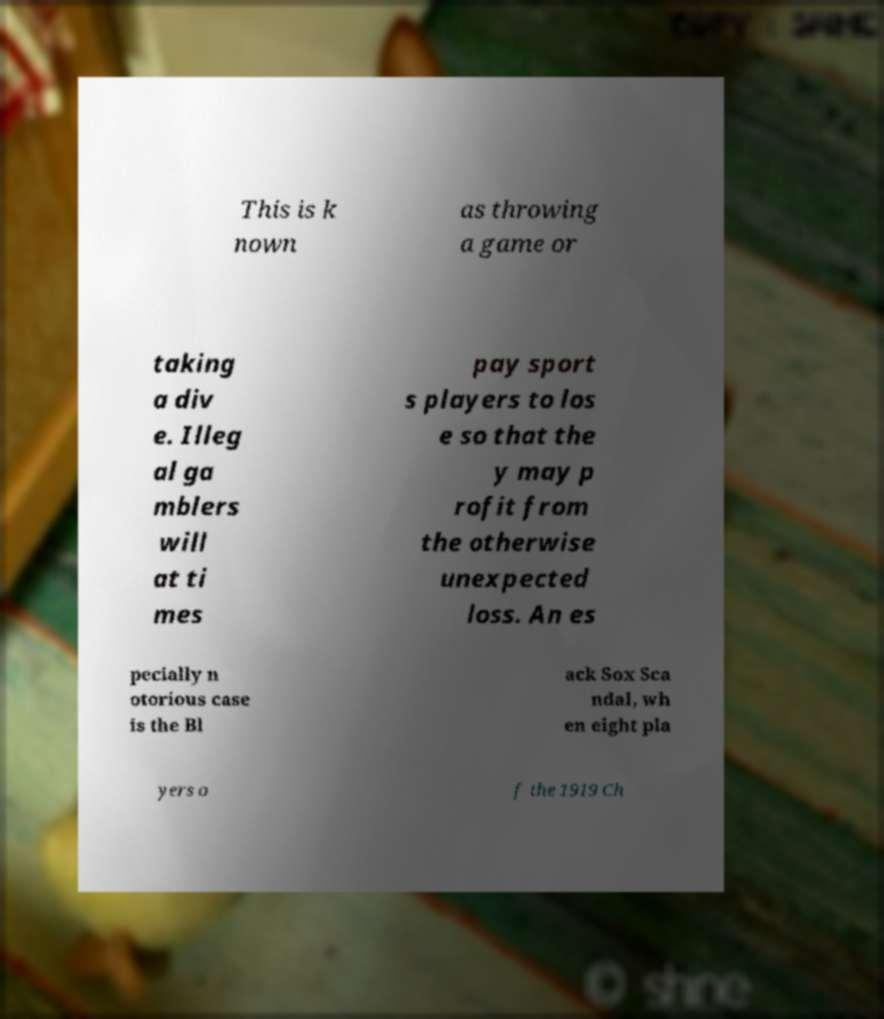Could you extract and type out the text from this image? This is k nown as throwing a game or taking a div e. Illeg al ga mblers will at ti mes pay sport s players to los e so that the y may p rofit from the otherwise unexpected loss. An es pecially n otorious case is the Bl ack Sox Sca ndal, wh en eight pla yers o f the 1919 Ch 